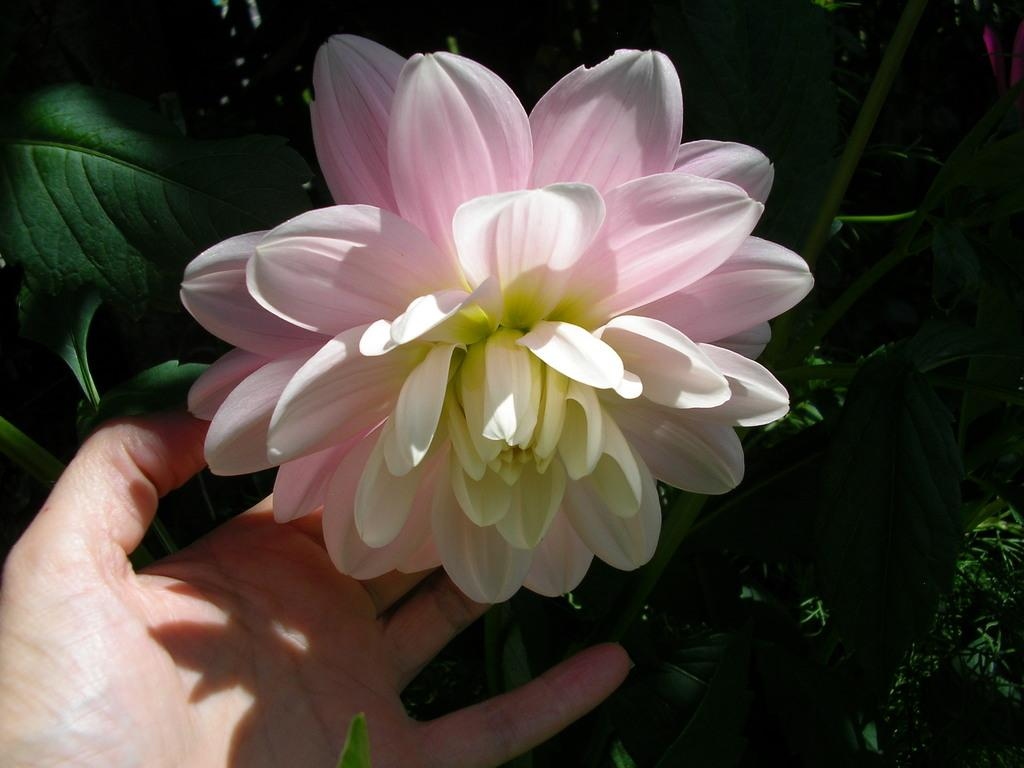What is the main subject of the image? The main subject of the image is a flower. Can you describe the colors of the flower? The flower has pink and white colors. What else is visible in the image besides the flower? There is a hand in the image. What can be seen in the background of the image? In the background, there are leaves on stems. What type of leather material can be seen in the image? There is no leather material present in the image. What power source is being used to keep the flower alive in the image? The image does not provide information about how the flower is being kept alive, and there is no mention of a power source. 